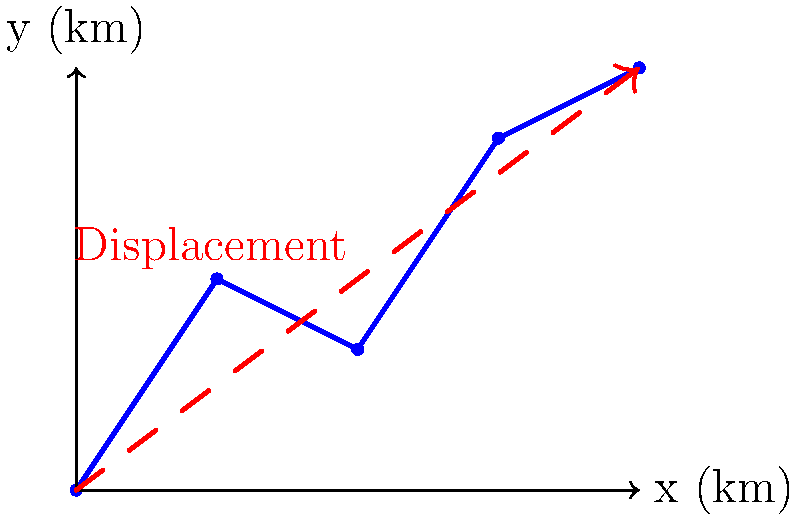A search and rescue dog follows a scent trail over varied terrain as shown in the blue path. The dog starts at (0,0) and ends at (4,3) km. What is the magnitude of the displacement vector for the dog's journey? To find the magnitude of the displacement vector, we need to follow these steps:

1. Identify the start and end points:
   Start: (0,0) km
   End: (4,3) km

2. Calculate the displacement vector components:
   $\Delta x = 4 - 0 = 4$ km
   $\Delta y = 3 - 0 = 3$ km

3. Use the Pythagorean theorem to find the magnitude of the displacement vector:
   $|\vec{d}| = \sqrt{(\Delta x)^2 + (\Delta y)^2}$

4. Substitute the values:
   $|\vec{d}| = \sqrt{4^2 + 3^2}$

5. Calculate:
   $|\vec{d}| = \sqrt{16 + 9} = \sqrt{25} = 5$ km

Therefore, the magnitude of the displacement vector is 5 km.
Answer: 5 km 